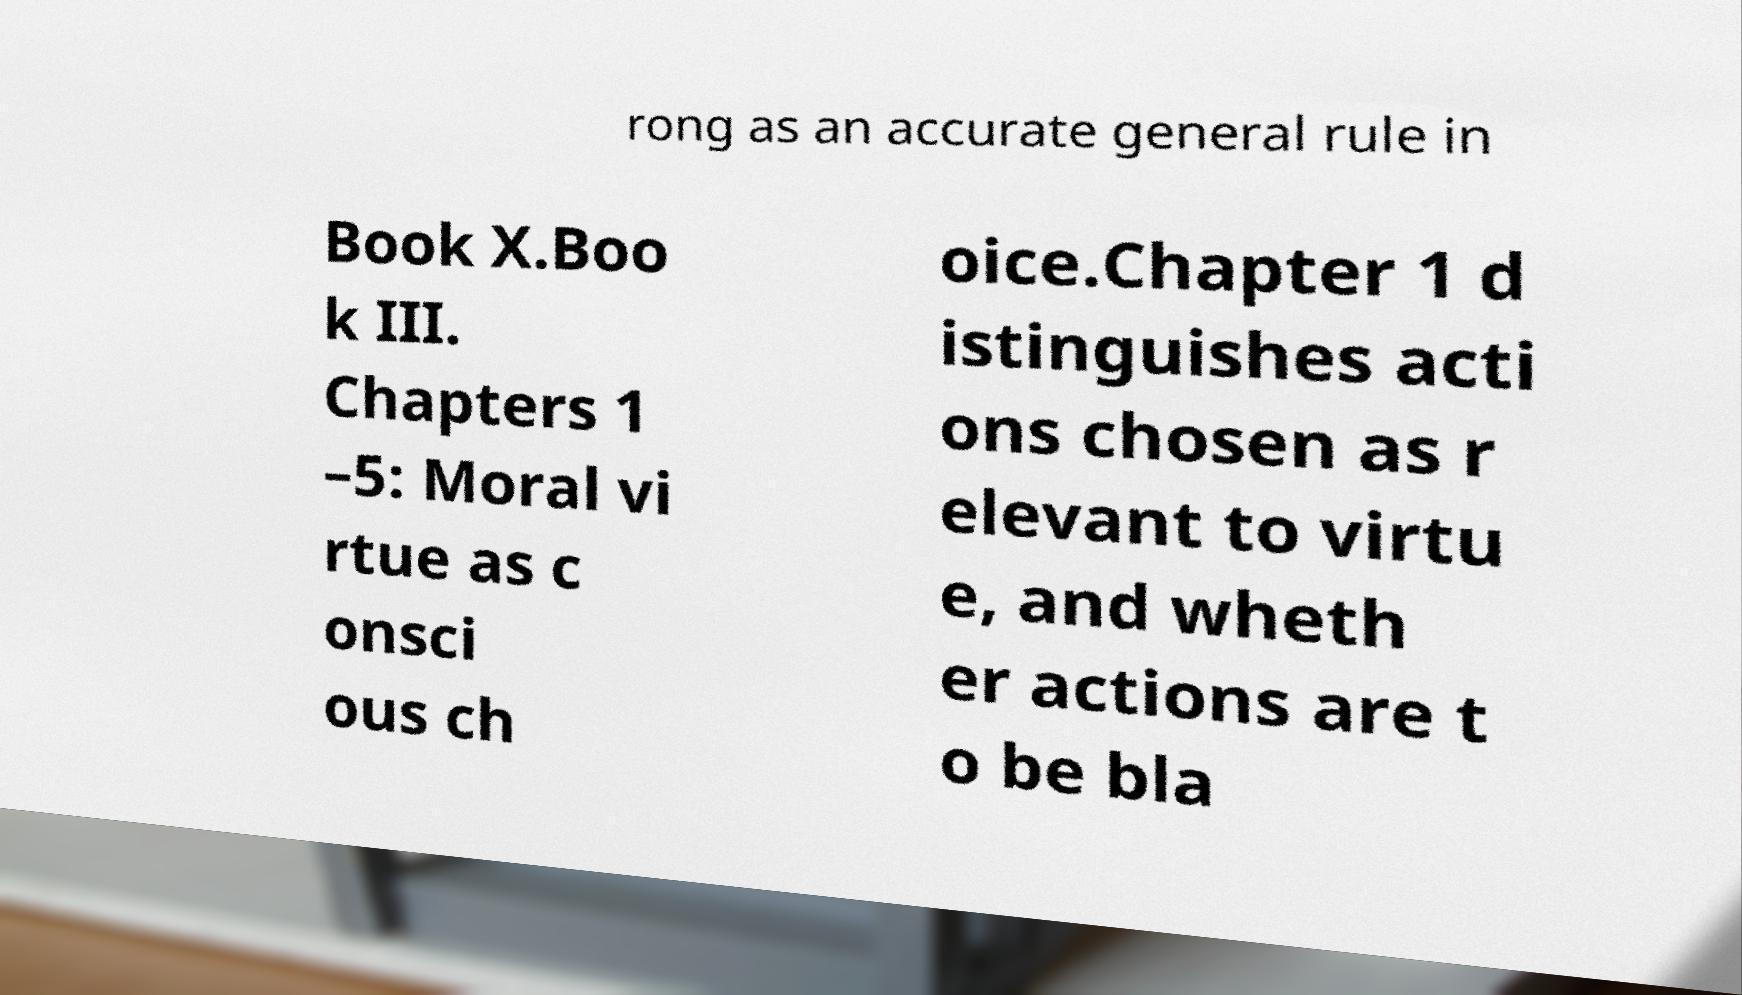For documentation purposes, I need the text within this image transcribed. Could you provide that? rong as an accurate general rule in Book X.Boo k III. Chapters 1 –5: Moral vi rtue as c onsci ous ch oice.Chapter 1 d istinguishes acti ons chosen as r elevant to virtu e, and wheth er actions are t o be bla 